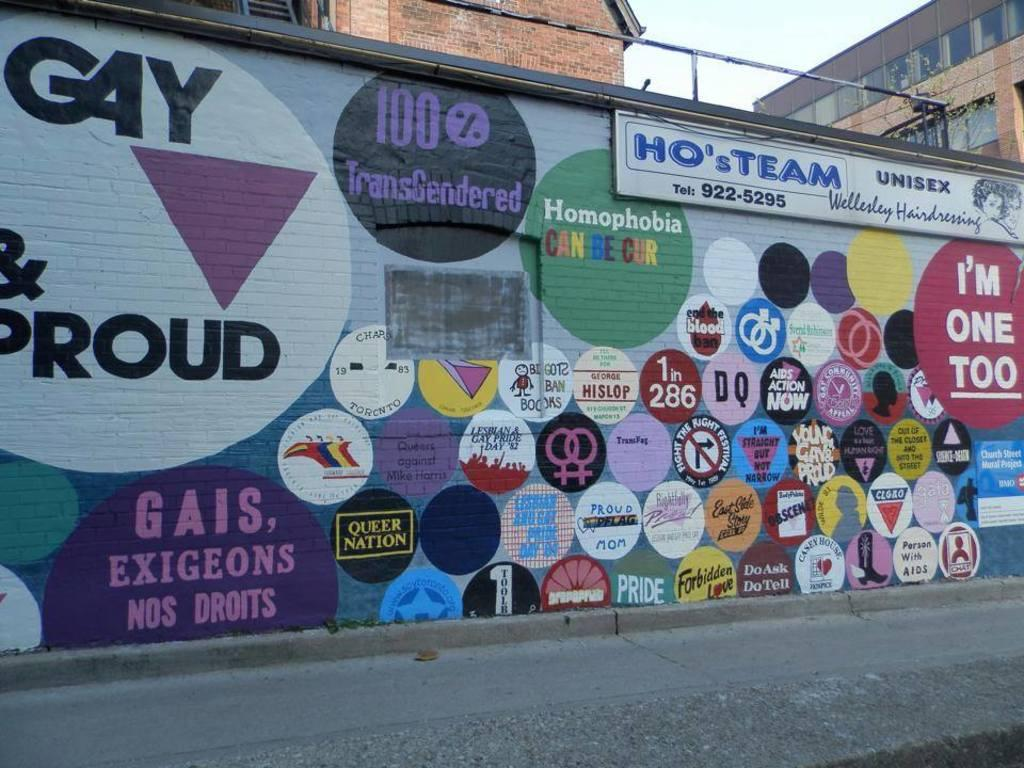<image>
Provide a brief description of the given image. A sign for a salon has the name of the business, Ho's Team, in blue. 